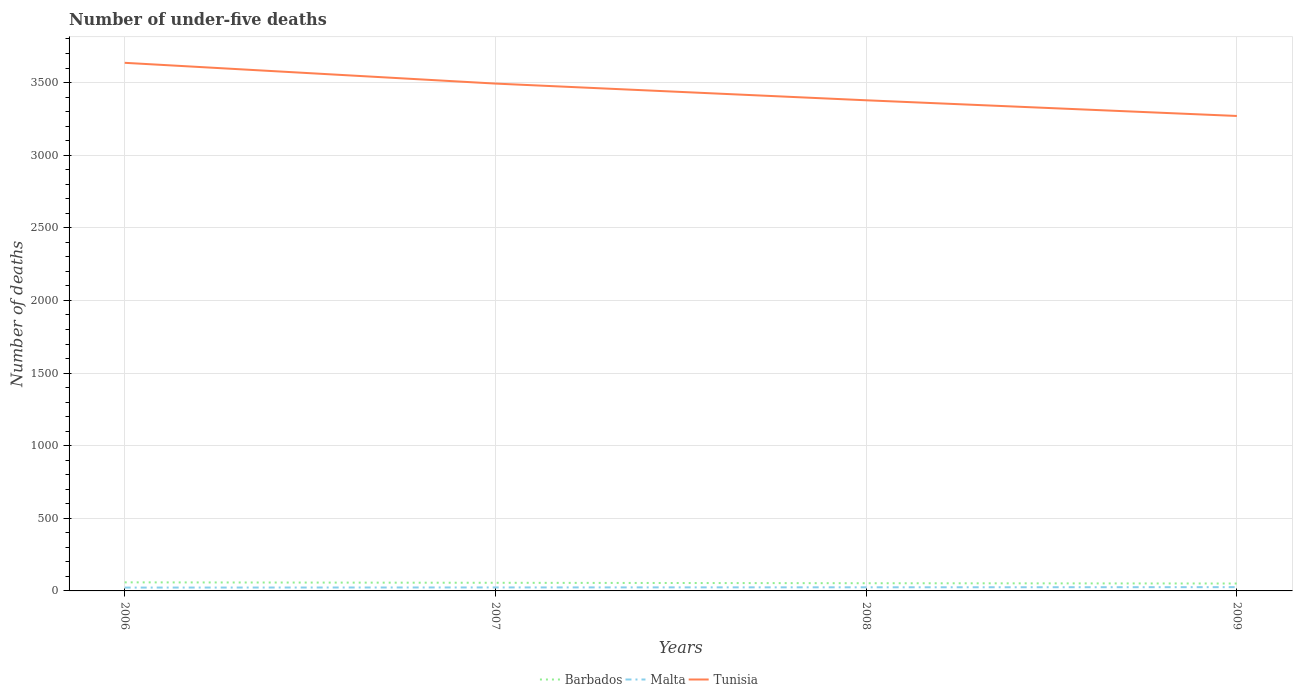Does the line corresponding to Malta intersect with the line corresponding to Tunisia?
Keep it short and to the point. No. Is the number of lines equal to the number of legend labels?
Your answer should be compact. Yes. Across all years, what is the maximum number of under-five deaths in Barbados?
Offer a very short reply. 51. What is the total number of under-five deaths in Barbados in the graph?
Give a very brief answer. 3. What is the difference between the highest and the second highest number of under-five deaths in Tunisia?
Provide a short and direct response. 366. What is the difference between the highest and the lowest number of under-five deaths in Tunisia?
Your response must be concise. 2. How many lines are there?
Your response must be concise. 3. How many years are there in the graph?
Ensure brevity in your answer.  4. What is the difference between two consecutive major ticks on the Y-axis?
Your answer should be compact. 500. Does the graph contain any zero values?
Give a very brief answer. No. How are the legend labels stacked?
Offer a terse response. Horizontal. What is the title of the graph?
Your answer should be compact. Number of under-five deaths. What is the label or title of the Y-axis?
Keep it short and to the point. Number of deaths. What is the Number of deaths of Barbados in 2006?
Give a very brief answer. 59. What is the Number of deaths of Malta in 2006?
Make the answer very short. 23. What is the Number of deaths in Tunisia in 2006?
Your response must be concise. 3636. What is the Number of deaths in Barbados in 2007?
Keep it short and to the point. 56. What is the Number of deaths in Tunisia in 2007?
Your response must be concise. 3493. What is the Number of deaths in Malta in 2008?
Offer a terse response. 25. What is the Number of deaths of Tunisia in 2008?
Your response must be concise. 3378. What is the Number of deaths of Malta in 2009?
Your answer should be compact. 26. What is the Number of deaths in Tunisia in 2009?
Provide a short and direct response. 3270. Across all years, what is the maximum Number of deaths in Malta?
Your answer should be very brief. 26. Across all years, what is the maximum Number of deaths of Tunisia?
Keep it short and to the point. 3636. Across all years, what is the minimum Number of deaths in Malta?
Ensure brevity in your answer.  23. Across all years, what is the minimum Number of deaths of Tunisia?
Your answer should be very brief. 3270. What is the total Number of deaths in Barbados in the graph?
Your answer should be compact. 219. What is the total Number of deaths in Malta in the graph?
Your answer should be very brief. 98. What is the total Number of deaths in Tunisia in the graph?
Keep it short and to the point. 1.38e+04. What is the difference between the Number of deaths in Barbados in 2006 and that in 2007?
Your answer should be very brief. 3. What is the difference between the Number of deaths of Malta in 2006 and that in 2007?
Ensure brevity in your answer.  -1. What is the difference between the Number of deaths of Tunisia in 2006 and that in 2007?
Provide a succinct answer. 143. What is the difference between the Number of deaths in Tunisia in 2006 and that in 2008?
Provide a succinct answer. 258. What is the difference between the Number of deaths in Tunisia in 2006 and that in 2009?
Give a very brief answer. 366. What is the difference between the Number of deaths in Malta in 2007 and that in 2008?
Your response must be concise. -1. What is the difference between the Number of deaths in Tunisia in 2007 and that in 2008?
Offer a terse response. 115. What is the difference between the Number of deaths in Barbados in 2007 and that in 2009?
Offer a terse response. 5. What is the difference between the Number of deaths in Malta in 2007 and that in 2009?
Keep it short and to the point. -2. What is the difference between the Number of deaths of Tunisia in 2007 and that in 2009?
Your answer should be compact. 223. What is the difference between the Number of deaths in Barbados in 2008 and that in 2009?
Ensure brevity in your answer.  2. What is the difference between the Number of deaths in Tunisia in 2008 and that in 2009?
Your answer should be compact. 108. What is the difference between the Number of deaths in Barbados in 2006 and the Number of deaths in Tunisia in 2007?
Keep it short and to the point. -3434. What is the difference between the Number of deaths in Malta in 2006 and the Number of deaths in Tunisia in 2007?
Offer a very short reply. -3470. What is the difference between the Number of deaths in Barbados in 2006 and the Number of deaths in Tunisia in 2008?
Your answer should be compact. -3319. What is the difference between the Number of deaths of Malta in 2006 and the Number of deaths of Tunisia in 2008?
Your answer should be compact. -3355. What is the difference between the Number of deaths of Barbados in 2006 and the Number of deaths of Malta in 2009?
Offer a very short reply. 33. What is the difference between the Number of deaths of Barbados in 2006 and the Number of deaths of Tunisia in 2009?
Offer a very short reply. -3211. What is the difference between the Number of deaths of Malta in 2006 and the Number of deaths of Tunisia in 2009?
Provide a short and direct response. -3247. What is the difference between the Number of deaths of Barbados in 2007 and the Number of deaths of Tunisia in 2008?
Make the answer very short. -3322. What is the difference between the Number of deaths of Malta in 2007 and the Number of deaths of Tunisia in 2008?
Ensure brevity in your answer.  -3354. What is the difference between the Number of deaths in Barbados in 2007 and the Number of deaths in Tunisia in 2009?
Give a very brief answer. -3214. What is the difference between the Number of deaths in Malta in 2007 and the Number of deaths in Tunisia in 2009?
Ensure brevity in your answer.  -3246. What is the difference between the Number of deaths of Barbados in 2008 and the Number of deaths of Malta in 2009?
Make the answer very short. 27. What is the difference between the Number of deaths of Barbados in 2008 and the Number of deaths of Tunisia in 2009?
Provide a succinct answer. -3217. What is the difference between the Number of deaths of Malta in 2008 and the Number of deaths of Tunisia in 2009?
Give a very brief answer. -3245. What is the average Number of deaths of Barbados per year?
Offer a very short reply. 54.75. What is the average Number of deaths of Malta per year?
Offer a very short reply. 24.5. What is the average Number of deaths in Tunisia per year?
Offer a terse response. 3444.25. In the year 2006, what is the difference between the Number of deaths of Barbados and Number of deaths of Malta?
Give a very brief answer. 36. In the year 2006, what is the difference between the Number of deaths in Barbados and Number of deaths in Tunisia?
Provide a short and direct response. -3577. In the year 2006, what is the difference between the Number of deaths of Malta and Number of deaths of Tunisia?
Ensure brevity in your answer.  -3613. In the year 2007, what is the difference between the Number of deaths of Barbados and Number of deaths of Malta?
Give a very brief answer. 32. In the year 2007, what is the difference between the Number of deaths of Barbados and Number of deaths of Tunisia?
Offer a very short reply. -3437. In the year 2007, what is the difference between the Number of deaths of Malta and Number of deaths of Tunisia?
Give a very brief answer. -3469. In the year 2008, what is the difference between the Number of deaths in Barbados and Number of deaths in Malta?
Make the answer very short. 28. In the year 2008, what is the difference between the Number of deaths in Barbados and Number of deaths in Tunisia?
Keep it short and to the point. -3325. In the year 2008, what is the difference between the Number of deaths of Malta and Number of deaths of Tunisia?
Offer a terse response. -3353. In the year 2009, what is the difference between the Number of deaths in Barbados and Number of deaths in Malta?
Offer a very short reply. 25. In the year 2009, what is the difference between the Number of deaths of Barbados and Number of deaths of Tunisia?
Ensure brevity in your answer.  -3219. In the year 2009, what is the difference between the Number of deaths in Malta and Number of deaths in Tunisia?
Your answer should be compact. -3244. What is the ratio of the Number of deaths of Barbados in 2006 to that in 2007?
Your answer should be very brief. 1.05. What is the ratio of the Number of deaths of Malta in 2006 to that in 2007?
Offer a very short reply. 0.96. What is the ratio of the Number of deaths of Tunisia in 2006 to that in 2007?
Ensure brevity in your answer.  1.04. What is the ratio of the Number of deaths in Barbados in 2006 to that in 2008?
Give a very brief answer. 1.11. What is the ratio of the Number of deaths in Malta in 2006 to that in 2008?
Offer a very short reply. 0.92. What is the ratio of the Number of deaths in Tunisia in 2006 to that in 2008?
Provide a succinct answer. 1.08. What is the ratio of the Number of deaths of Barbados in 2006 to that in 2009?
Provide a succinct answer. 1.16. What is the ratio of the Number of deaths in Malta in 2006 to that in 2009?
Keep it short and to the point. 0.88. What is the ratio of the Number of deaths in Tunisia in 2006 to that in 2009?
Give a very brief answer. 1.11. What is the ratio of the Number of deaths of Barbados in 2007 to that in 2008?
Provide a short and direct response. 1.06. What is the ratio of the Number of deaths of Malta in 2007 to that in 2008?
Provide a succinct answer. 0.96. What is the ratio of the Number of deaths of Tunisia in 2007 to that in 2008?
Give a very brief answer. 1.03. What is the ratio of the Number of deaths of Barbados in 2007 to that in 2009?
Ensure brevity in your answer.  1.1. What is the ratio of the Number of deaths of Tunisia in 2007 to that in 2009?
Make the answer very short. 1.07. What is the ratio of the Number of deaths of Barbados in 2008 to that in 2009?
Give a very brief answer. 1.04. What is the ratio of the Number of deaths in Malta in 2008 to that in 2009?
Keep it short and to the point. 0.96. What is the ratio of the Number of deaths in Tunisia in 2008 to that in 2009?
Offer a terse response. 1.03. What is the difference between the highest and the second highest Number of deaths of Malta?
Your answer should be compact. 1. What is the difference between the highest and the second highest Number of deaths in Tunisia?
Make the answer very short. 143. What is the difference between the highest and the lowest Number of deaths in Barbados?
Your answer should be compact. 8. What is the difference between the highest and the lowest Number of deaths in Malta?
Give a very brief answer. 3. What is the difference between the highest and the lowest Number of deaths of Tunisia?
Give a very brief answer. 366. 